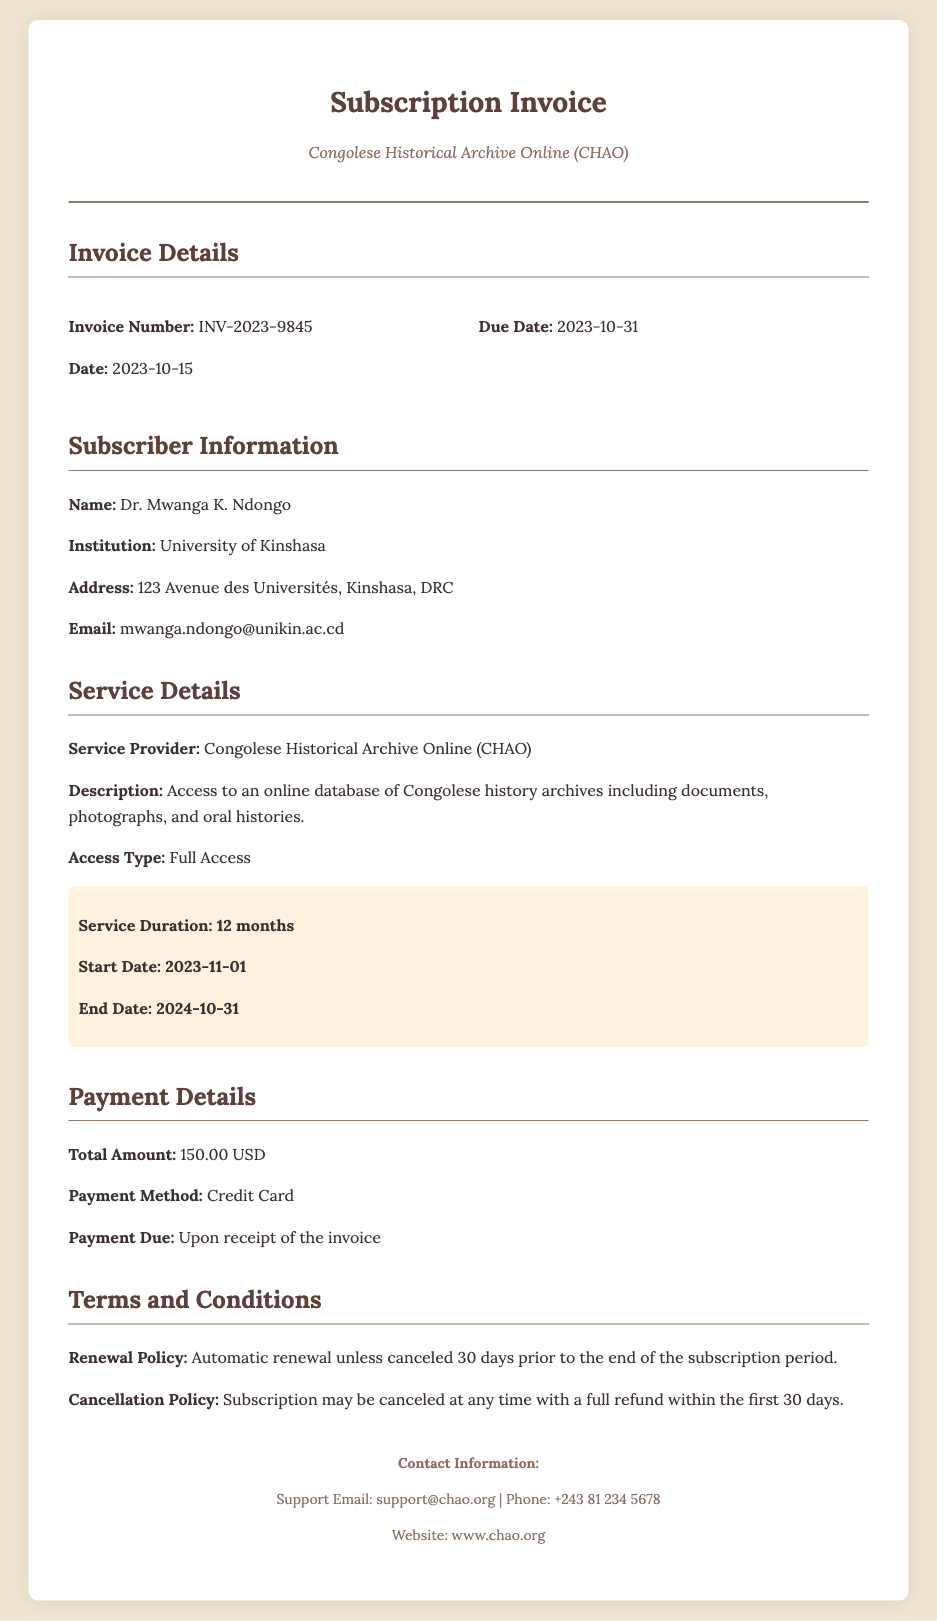What is the invoice number? The invoice number is provided in the invoice details section.
Answer: INV-2023-9845 What is the subscriber's name? The subscriber's name is mentioned in the subscriber information section.
Answer: Dr. Mwanga K. Ndongo What is the total amount due? The total amount due is listed in the payment details section.
Answer: 150.00 USD What is the service duration? The service duration is highlighted specifically within the service details section.
Answer: 12 months When does the subscription start? The start date of the subscription is included in the service details section.
Answer: 2023-11-01 What is the contact email provided for support? The contact email for support is listed in the footer of the document.
Answer: support@chao.org What is the payment method specified? The payment method is explicitly mentioned in the payment details section.
Answer: Credit Card What is the cancellation policy? The cancellation policy is described in the terms and conditions section.
Answer: Subscription may be canceled at any time with a full refund within the first 30 days 